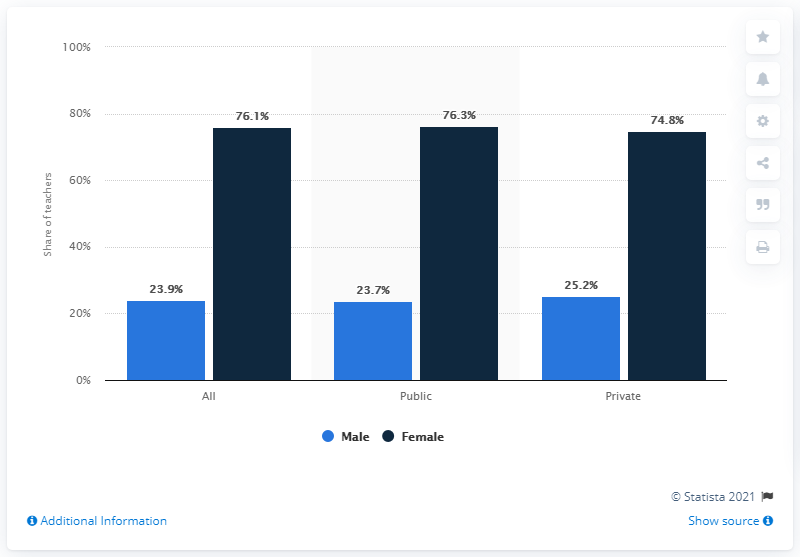Specify some key components in this picture. The average age of male teachers in both public and private schools is 24.45. The gender population that tend to become teachers is primarily female. In the 2011-2012 school year, 76.1% of all U.S. teachers were female. 